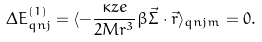<formula> <loc_0><loc_0><loc_500><loc_500>\Delta E ^ { ( 1 ) } _ { q n j } = \langle - \frac { \kappa z e } { 2 M r ^ { 3 } } \beta \vec { \Sigma } \cdot \vec { r } \rangle _ { q n j m } = 0 .</formula> 